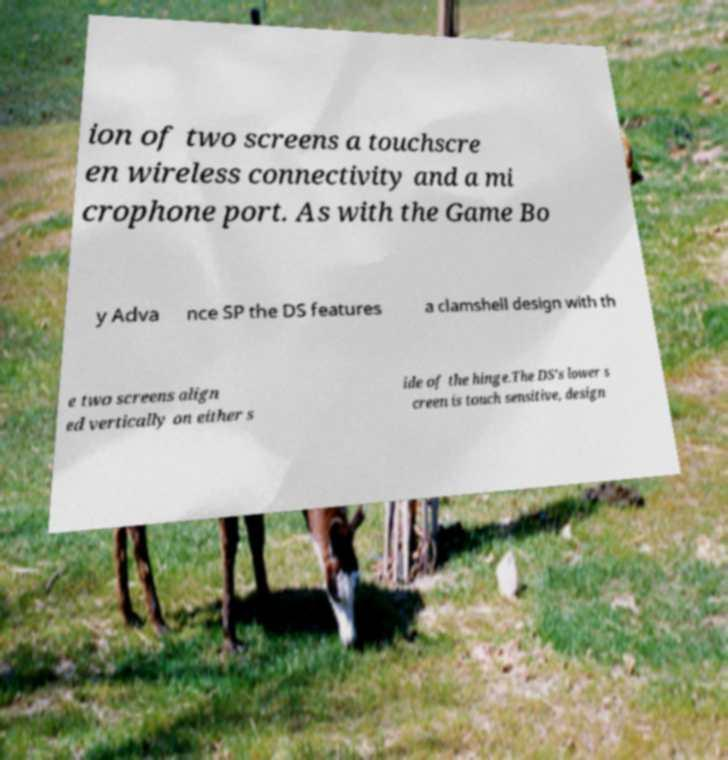Please read and relay the text visible in this image. What does it say? ion of two screens a touchscre en wireless connectivity and a mi crophone port. As with the Game Bo y Adva nce SP the DS features a clamshell design with th e two screens align ed vertically on either s ide of the hinge.The DS's lower s creen is touch sensitive, design 